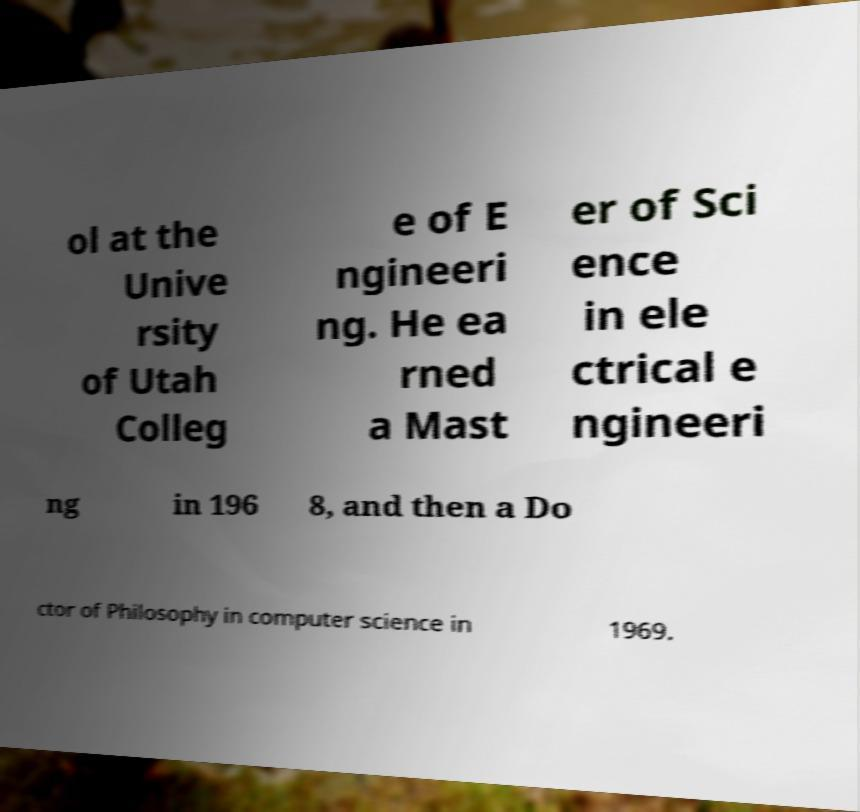Could you assist in decoding the text presented in this image and type it out clearly? ol at the Unive rsity of Utah Colleg e of E ngineeri ng. He ea rned a Mast er of Sci ence in ele ctrical e ngineeri ng in 196 8, and then a Do ctor of Philosophy in computer science in 1969. 